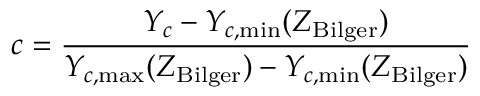Convert formula to latex. <formula><loc_0><loc_0><loc_500><loc_500>c = \frac { Y _ { c } - Y _ { c , \min } ( Z _ { B i l g e r } ) } { Y _ { c , \max } ( Z _ { B i l g e r } ) - Y _ { c , \min } ( Z _ { B i l g e r } ) }</formula> 